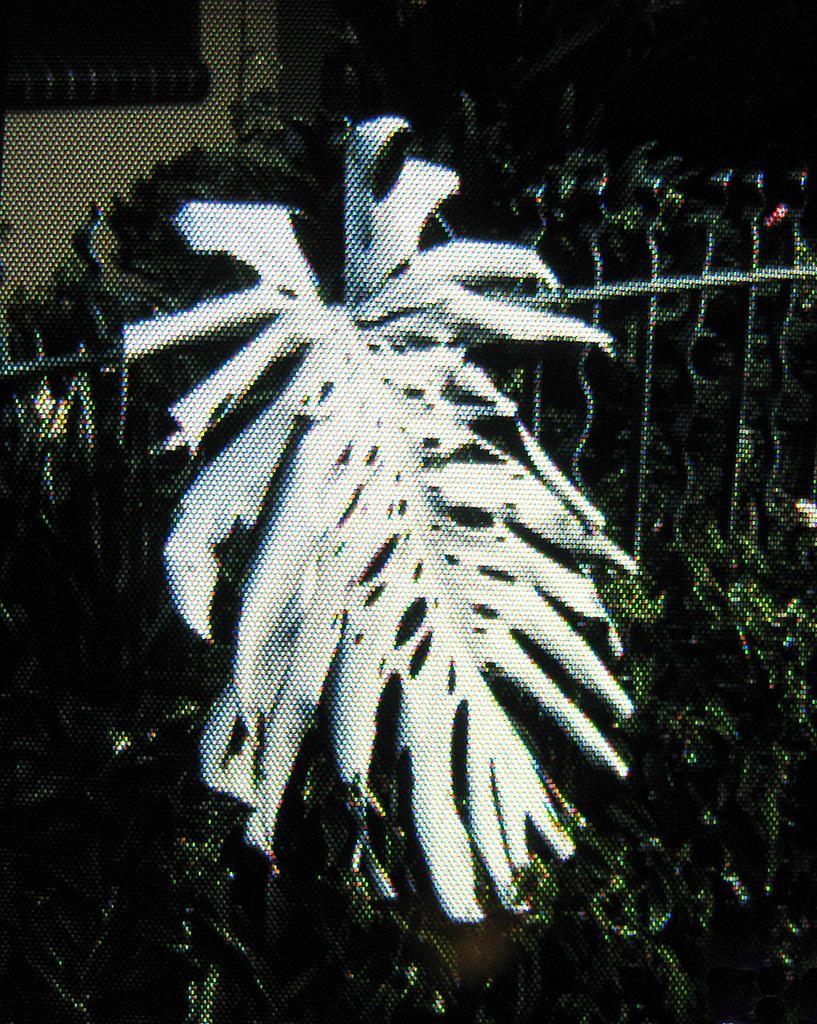Describe this image in one or two sentences. There a fencing in the middle of this image, and it seems like there are some plants at the bottom of this image and in the middle of this image as well. There is a wall in the background. 